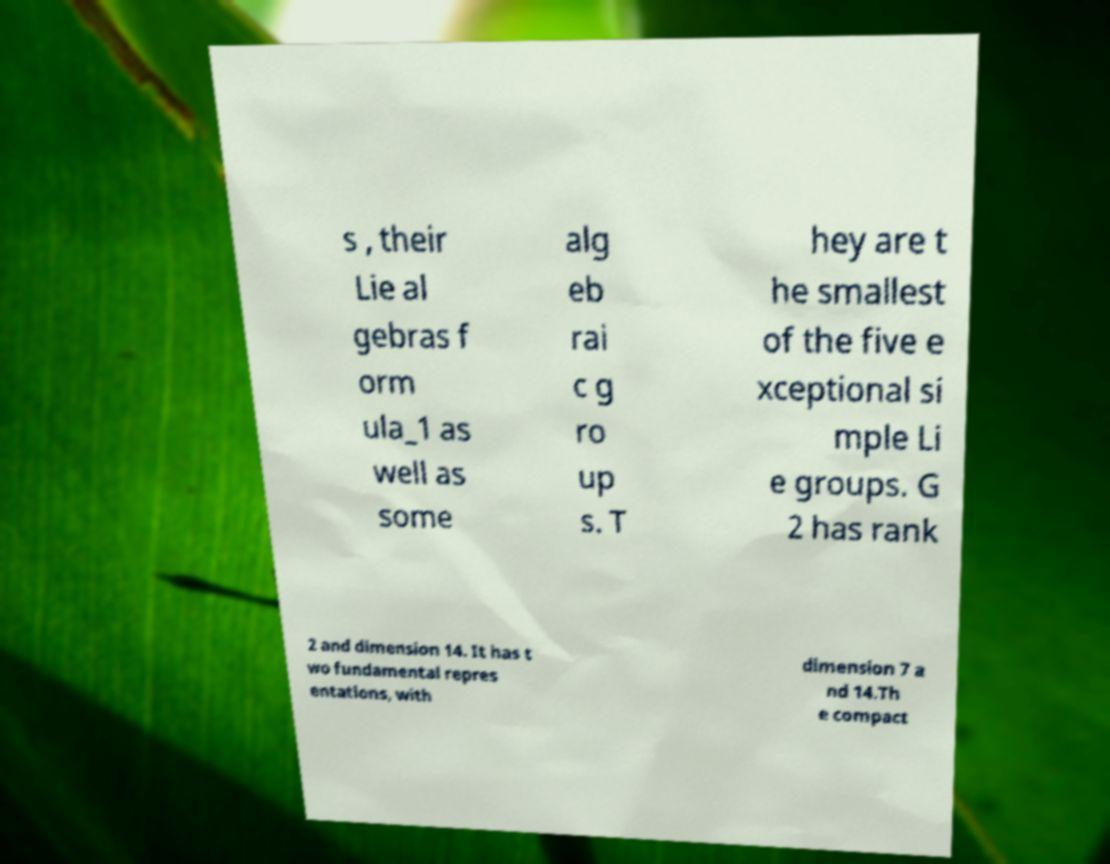There's text embedded in this image that I need extracted. Can you transcribe it verbatim? s , their Lie al gebras f orm ula_1 as well as some alg eb rai c g ro up s. T hey are t he smallest of the five e xceptional si mple Li e groups. G 2 has rank 2 and dimension 14. It has t wo fundamental repres entations, with dimension 7 a nd 14.Th e compact 